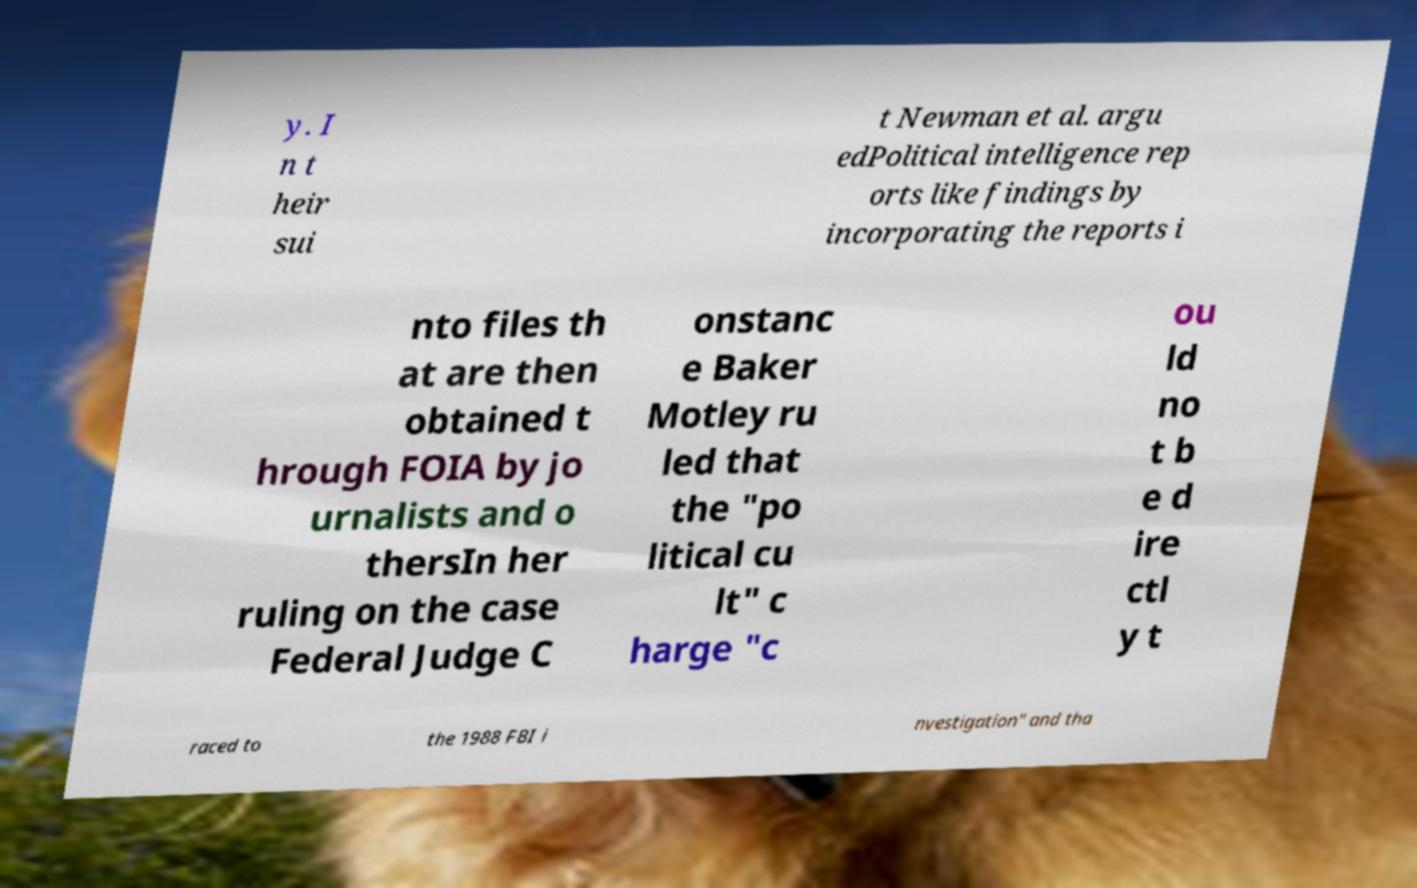Could you extract and type out the text from this image? y. I n t heir sui t Newman et al. argu edPolitical intelligence rep orts like findings by incorporating the reports i nto files th at are then obtained t hrough FOIA by jo urnalists and o thersIn her ruling on the case Federal Judge C onstanc e Baker Motley ru led that the "po litical cu lt" c harge "c ou ld no t b e d ire ctl y t raced to the 1988 FBI i nvestigation" and tha 